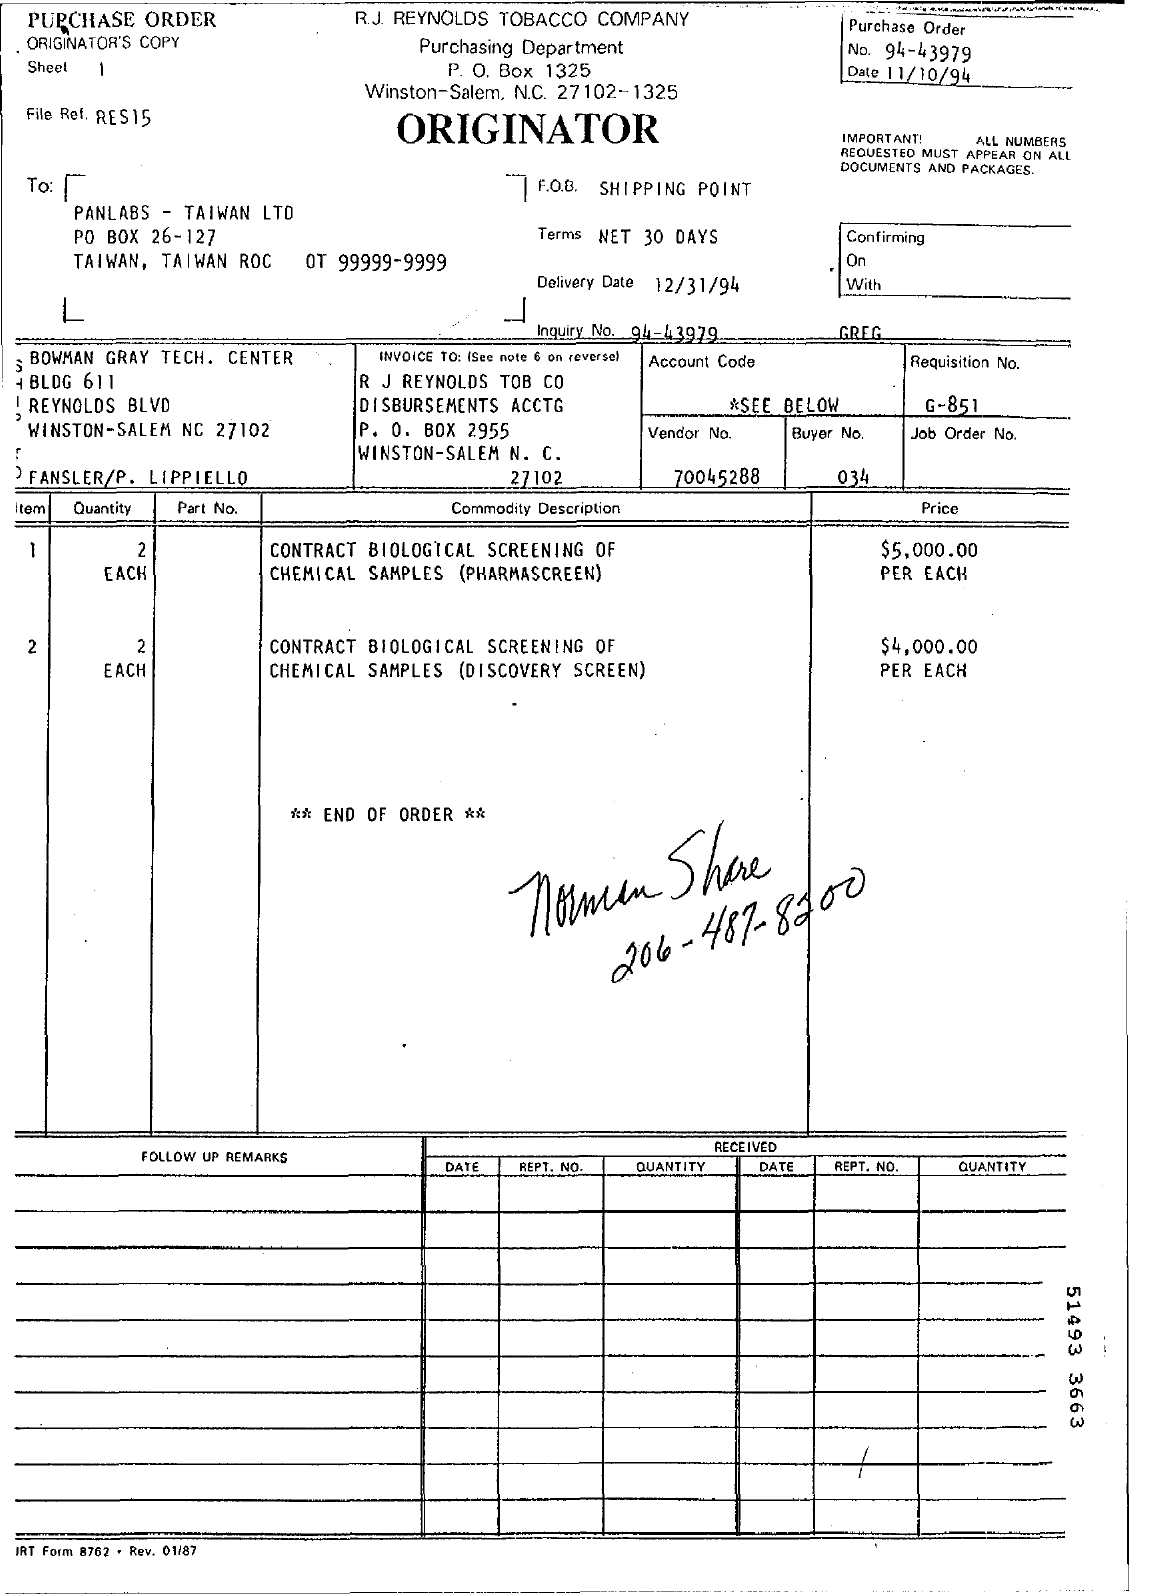Give some essential details in this illustration. What is Vendor No. 70045288..." is a question asking for information about a specific vendor number. 